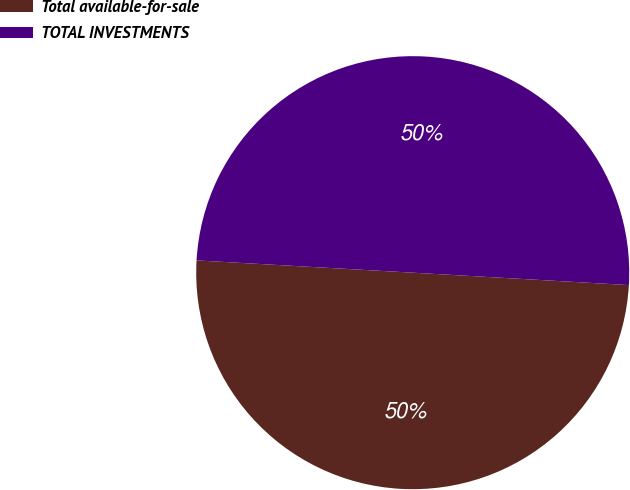Convert chart. <chart><loc_0><loc_0><loc_500><loc_500><pie_chart><fcel>Total available-for-sale<fcel>TOTAL INVESTMENTS<nl><fcel>49.99%<fcel>50.01%<nl></chart> 